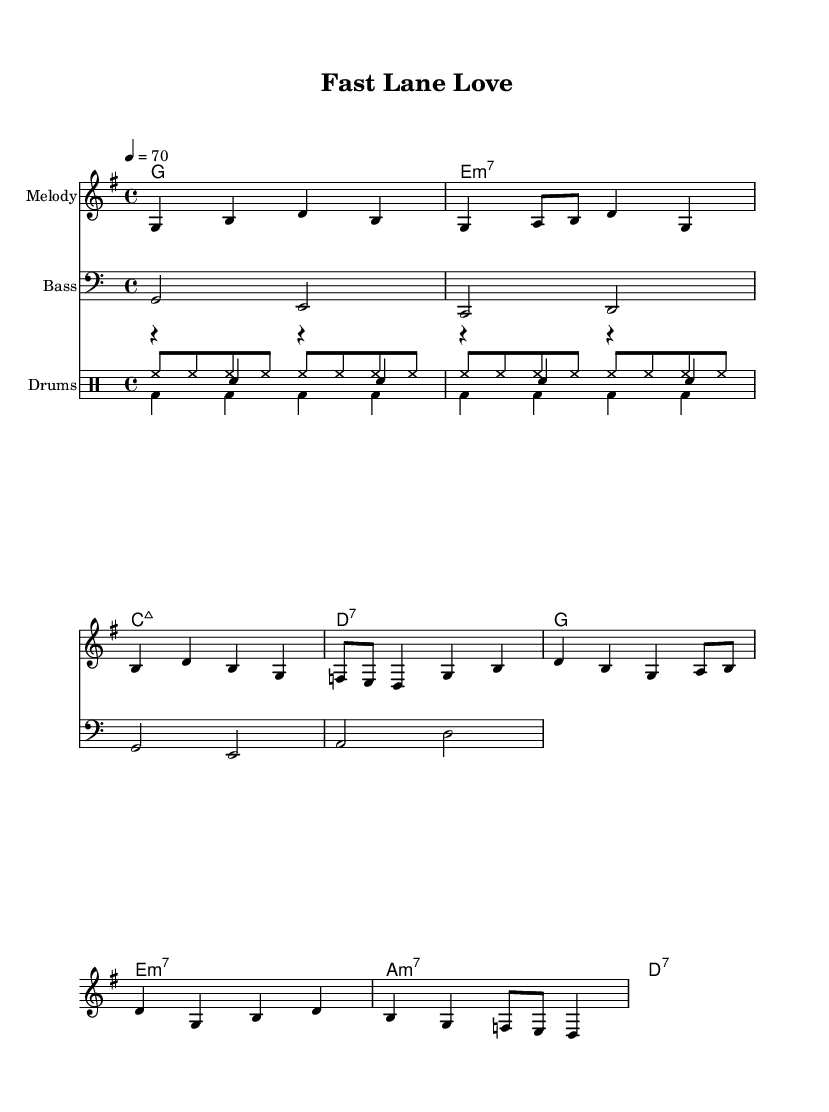What is the key signature of this music? The key signature is G major, which has one sharp (F#).
Answer: G major What is the time signature of this music? The time signature is 4/4, which means there are four beats in each measure.
Answer: 4/4 What is the tempo marking indicated in the music? The tempo marking is 70 beats per minute, indicating the speed of the piece.
Answer: 70 Which chord follows the G major chord in the progression? After the G major chord, the next chord in the progression is E minor 7, as seen in the chord mode section.
Answer: E minor 7 How many measures are used in the melody? The melody consists of eight measures, as indicated by the grouping of notes and rests.
Answer: Eight What lyrical theme is represented in the song? The lyrics express a racing metaphor as a symbol of love and life's journey, with references to a "checker flag" and "shifting gears."
Answer: Racing metaphor What is the bass clef's first note played in the composition? The first note in the bass line is G, as shown by the note placement in the bass staff.
Answer: G 